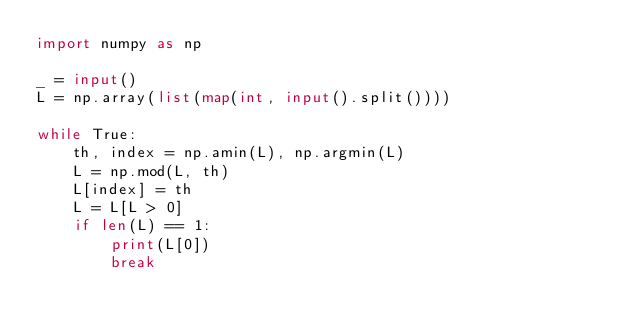Convert code to text. <code><loc_0><loc_0><loc_500><loc_500><_Python_>import numpy as np

_ = input()
L = np.array(list(map(int, input().split())))

while True:
    th, index = np.amin(L), np.argmin(L)
    L = np.mod(L, th)
    L[index] = th
    L = L[L > 0]
    if len(L) == 1:
        print(L[0])
        break</code> 